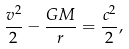Convert formula to latex. <formula><loc_0><loc_0><loc_500><loc_500>\frac { v ^ { 2 } } { 2 } - \frac { G M } { r } = \frac { c ^ { 2 } } { 2 } ,</formula> 